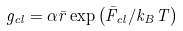Convert formula to latex. <formula><loc_0><loc_0><loc_500><loc_500>g _ { c l } = \alpha \bar { r } \exp \left ( \bar { F } _ { c l } / k _ { B } T \right )</formula> 